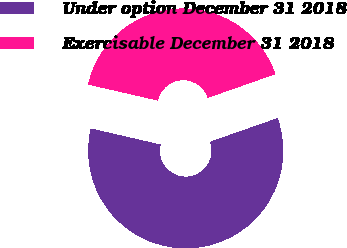<chart> <loc_0><loc_0><loc_500><loc_500><pie_chart><fcel>Under option December 31 2018<fcel>Exercisable December 31 2018<nl><fcel>58.97%<fcel>41.03%<nl></chart> 